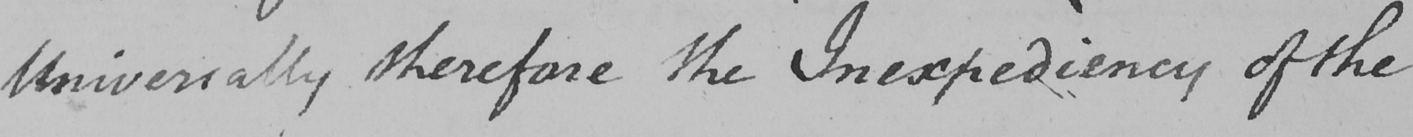Can you tell me what this handwritten text says? Universally therefore the Inexpediency of the 